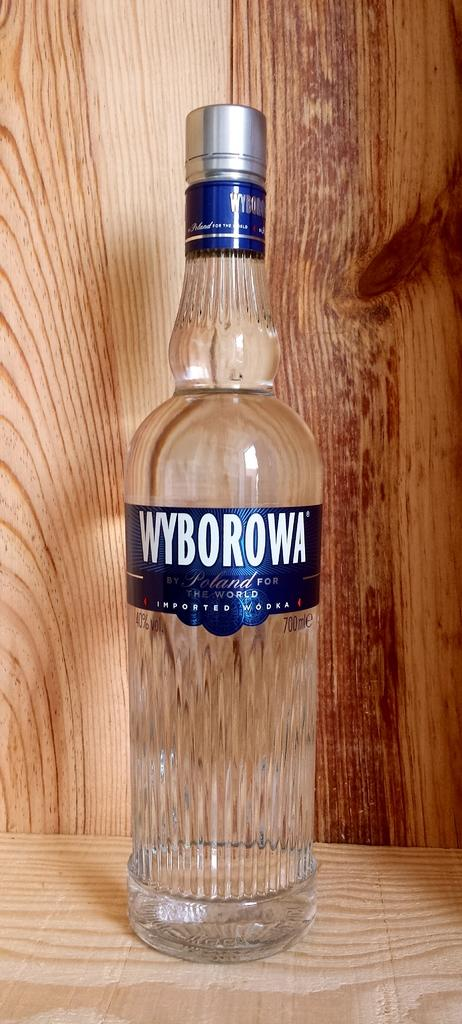What object can be seen in the image? There is a bottle in the image. Where is the bottle located? The bottle is on a table. What rhythm does the bottle follow in the image? The bottle does not follow any rhythm in the image; it is a static object. 